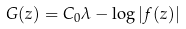Convert formula to latex. <formula><loc_0><loc_0><loc_500><loc_500>G ( z ) = C _ { 0 } \lambda - \log | f ( z ) |</formula> 